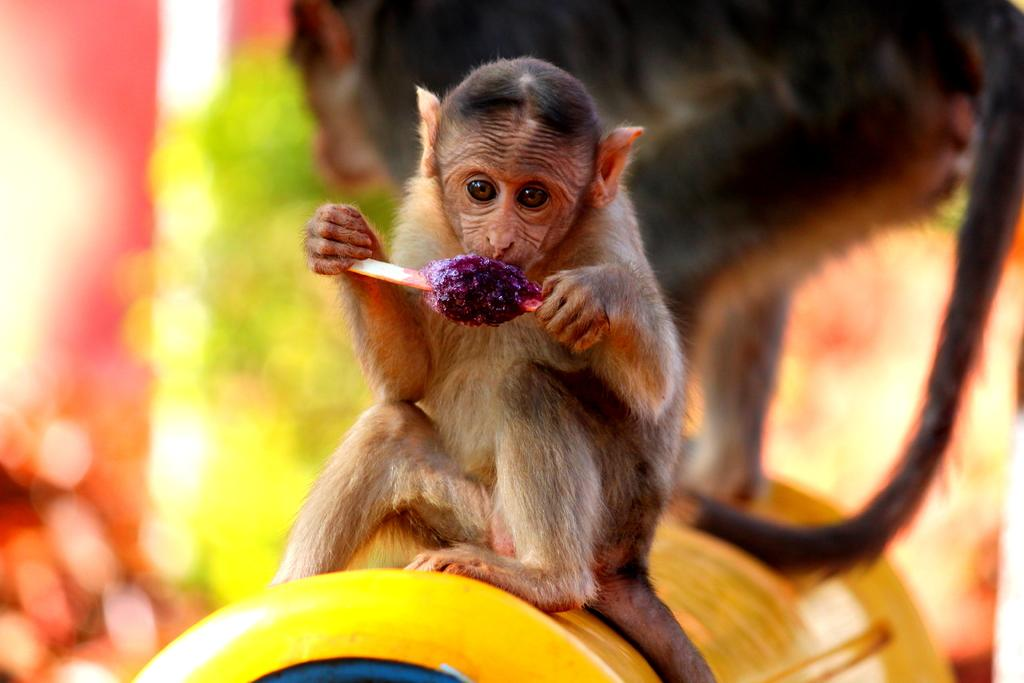What animal is the main subject of the image? There is a monkey in the image. What is the monkey doing in the image? The monkey is sitting and eating an ice cola. Are there any other monkeys visible in the image? Yes, there is another monkey in the background of the image. What type of art is being exchanged between the monkeys in the image? There is no art being exchanged between the monkeys in the image; they are simply sitting and eating ice cola. Can you tell me if the monkeys in the image are spying on each other? There is no indication in the image that the monkeys are spying on each other; they are just sitting and eating ice cola. 